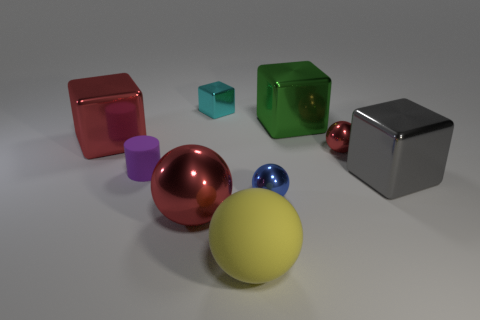Subtract all cyan cubes. How many cubes are left? 3 Add 1 small gray cylinders. How many objects exist? 10 Subtract 1 spheres. How many spheres are left? 3 Subtract all purple blocks. Subtract all cyan balls. How many blocks are left? 4 Subtract all cylinders. How many objects are left? 8 Add 6 gray objects. How many gray objects are left? 7 Add 8 gray metal balls. How many gray metal balls exist? 8 Subtract 0 blue cylinders. How many objects are left? 9 Subtract all tiny shiny cubes. Subtract all red objects. How many objects are left? 5 